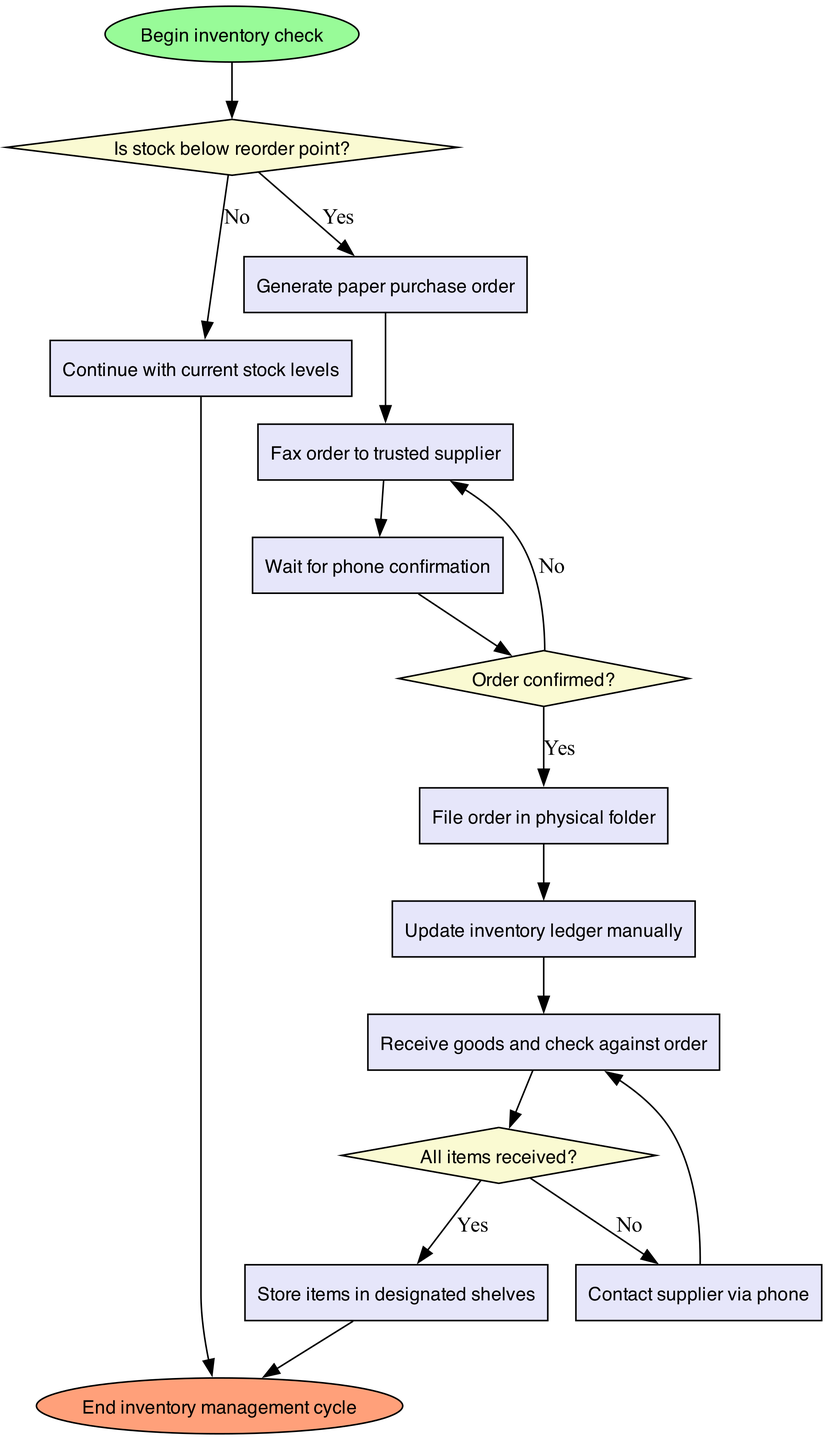What is the first node in the diagram? The first node in the diagram is labeled "Begin inventory check", indicating the start of the inventory management process.
Answer: Begin inventory check How many decision nodes are present in the diagram? There are three decision nodes in the diagram, which are represented as diamonds making choices about stock levels and order confirmations.
Answer: 3 What happens if the stock is below the reorder point? If stock is below the reorder point, the process moves to generate a paper purchase order, indicating that action is required to replenish inventory.
Answer: Generate paper purchase order What is the final node in the flowchart? The final node in the flowchart is labeled "End inventory management cycle", which indicates the completion of the inventory management process.
Answer: End inventory management cycle What process follows the confirmation of the order? After confirming the order, the next process involves filing the order in a physical folder to keep records of the transaction.
Answer: File order in physical folder If all items are received, what is the next process? If all items are received, the next process is to store the items in designated shelves, indicating that the inventory has been successfully updated.
Answer: Store items in designated shelves What action is taken if the order is not confirmed? If the order is not confirmed, the action taken is to contact the supplier via phone to ensure that the order is properly addressed and confirmed.
Answer: Contact supplier via phone What happens after updating the inventory ledger manually? After updating the inventory ledger manually, the process is to receive goods and check them against the order to ensure all items are accounted for.
Answer: Receive goods and check against order 